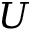<formula> <loc_0><loc_0><loc_500><loc_500>U</formula> 